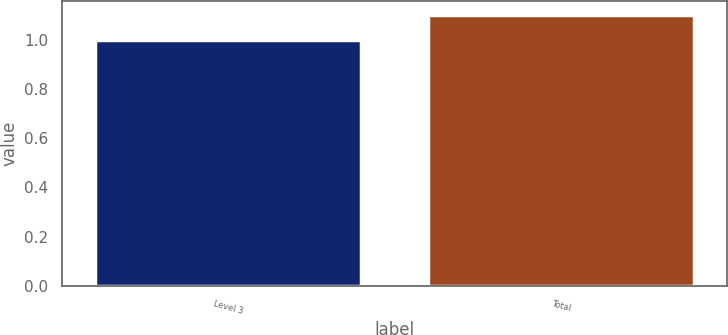Convert chart. <chart><loc_0><loc_0><loc_500><loc_500><bar_chart><fcel>Level 3<fcel>Total<nl><fcel>1<fcel>1.1<nl></chart> 